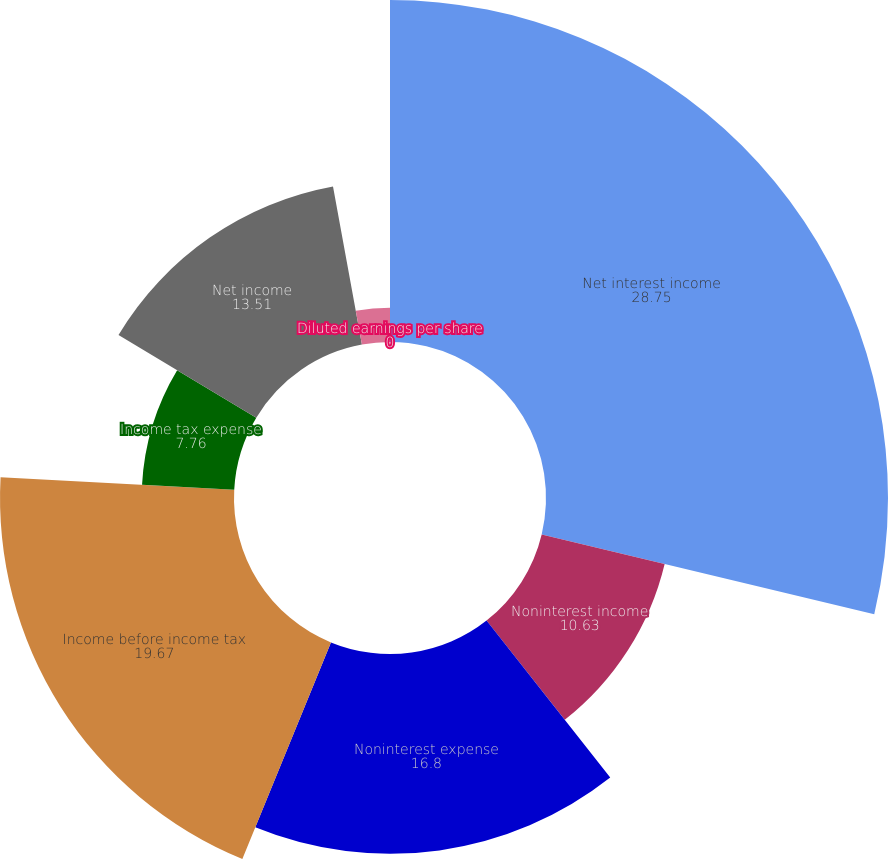Convert chart. <chart><loc_0><loc_0><loc_500><loc_500><pie_chart><fcel>Net interest income<fcel>Noninterest income<fcel>Noninterest expense<fcel>Income before income tax<fcel>Income tax expense<fcel>Net income<fcel>Basic earnings per share<fcel>Diluted earnings per share<nl><fcel>28.75%<fcel>10.63%<fcel>16.8%<fcel>19.67%<fcel>7.76%<fcel>13.51%<fcel>2.88%<fcel>0.0%<nl></chart> 